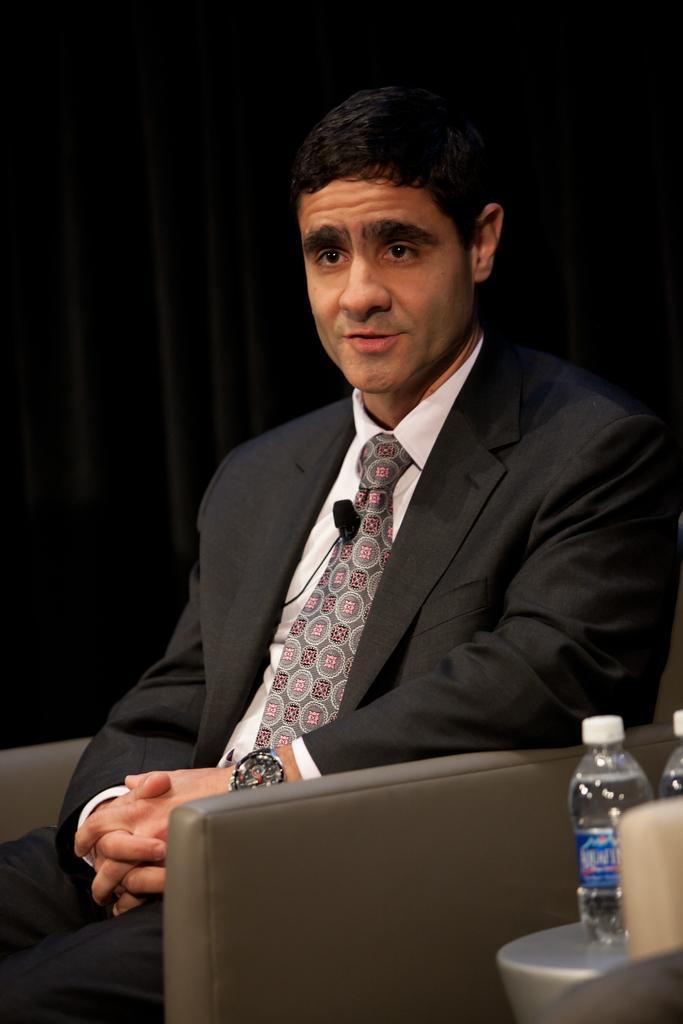Describe this image in one or two sentences. In this image I can see a man wearing suit and sitting on the chair. He's wearing a watch to his left hand. In the background I can see a black color curtain. On the right side of the image I can see two bottles. 